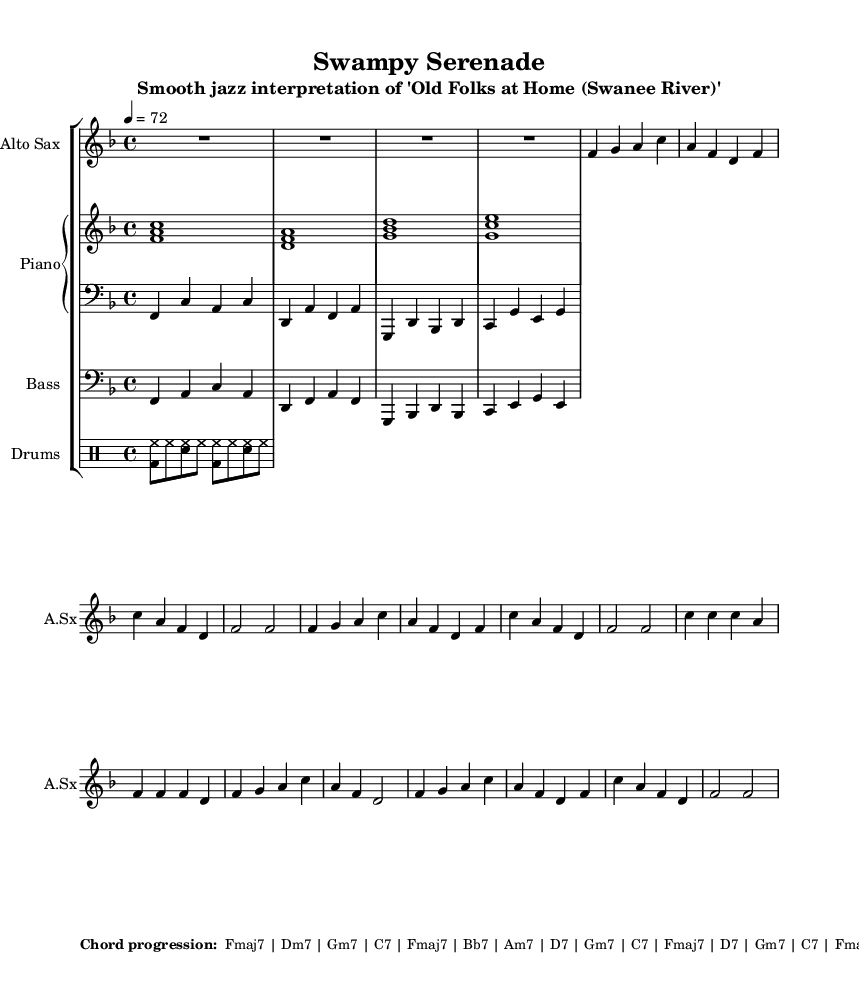What is the key signature of this music? The key signature is F major, which has one flat (B♭). This can be determined by looking at the key signature notation at the beginning of the score.
Answer: F major What is the time signature of the piece? The time signature is 4/4, indicated at the beginning of the score. This means there are four beats in each measure and the quarter note receives one beat.
Answer: 4/4 What is the tempo marking for this piece? The tempo marking indicates a speed of 72 beats per minute, which is noted as "4 = 72" at the beginning. This tells us the piece should be played moderately slow.
Answer: 72 What is the main instrument featured in this score? The main instrument featured is the Alto Saxophone, which is specified at the beginning of the saxophone staff. This typically leads the melody in a jazz arrangement.
Answer: Alto Sax How many measures are in the first section of the saxophone music? The first section of the saxophone music contains eight measures. By counting the vertical lines that separate the measures in the saxophone part, we reach this total.
Answer: 8 What is the chord in the first measure of the piano right-hand part? The chord in the first measure is F major (F, A, C), as indicated by the notes stacked together in that measure. This chord is fundamental in establishing the harmonic base of the piece.
Answer: F major What jazz characteristic is evident in this arrangement? A prominent characteristic of jazz evident in this arrangement is syncopation, especially in the rhythm, where expected beats are accented, creating a laid-back feel typical of smooth jazz. This can be heard when observing the interplay between the saxophone and the rhythm section.
Answer: Syncopation 